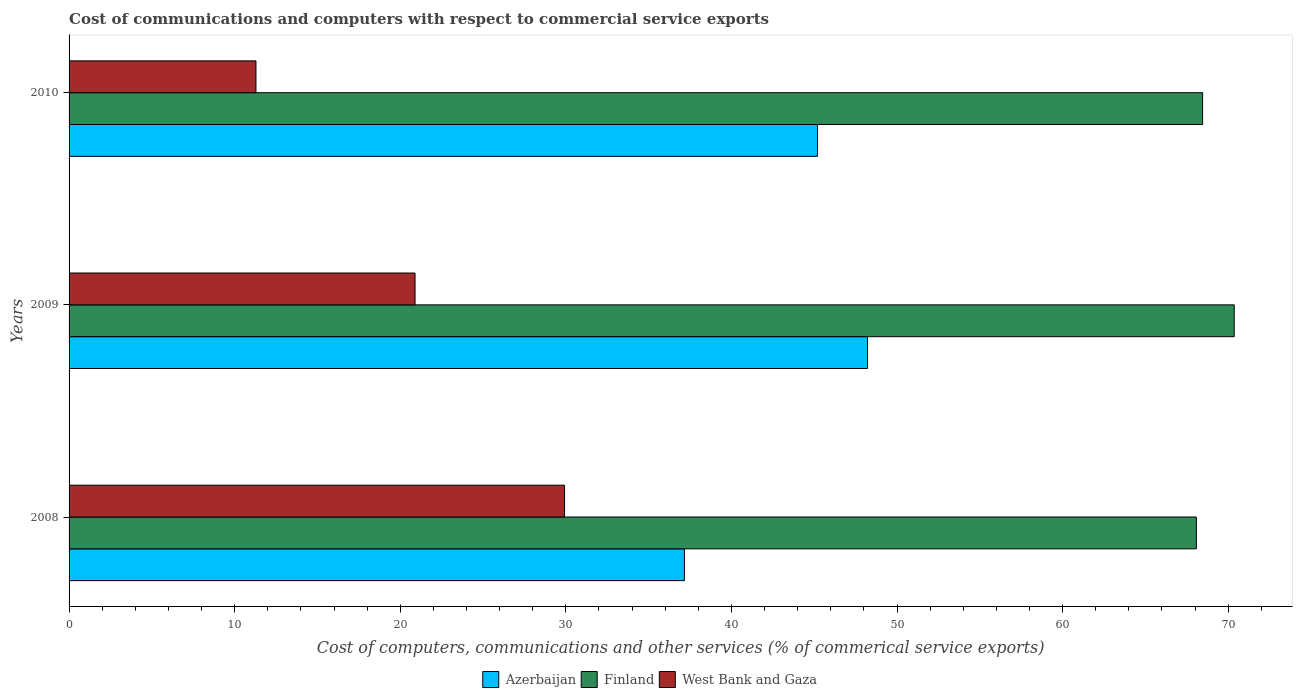How many different coloured bars are there?
Make the answer very short. 3. Are the number of bars per tick equal to the number of legend labels?
Your response must be concise. Yes. How many bars are there on the 2nd tick from the top?
Ensure brevity in your answer.  3. What is the label of the 1st group of bars from the top?
Your response must be concise. 2010. In how many cases, is the number of bars for a given year not equal to the number of legend labels?
Provide a short and direct response. 0. What is the cost of communications and computers in Finland in 2010?
Make the answer very short. 68.46. Across all years, what is the maximum cost of communications and computers in Azerbaijan?
Your answer should be very brief. 48.22. Across all years, what is the minimum cost of communications and computers in West Bank and Gaza?
Your response must be concise. 11.29. In which year was the cost of communications and computers in West Bank and Gaza maximum?
Provide a succinct answer. 2008. In which year was the cost of communications and computers in Finland minimum?
Your answer should be compact. 2008. What is the total cost of communications and computers in Azerbaijan in the graph?
Your answer should be compact. 130.58. What is the difference between the cost of communications and computers in West Bank and Gaza in 2008 and that in 2009?
Your answer should be compact. 9.03. What is the difference between the cost of communications and computers in West Bank and Gaza in 2009 and the cost of communications and computers in Finland in 2008?
Your answer should be compact. -47.19. What is the average cost of communications and computers in West Bank and Gaza per year?
Your answer should be very brief. 20.7. In the year 2008, what is the difference between the cost of communications and computers in Finland and cost of communications and computers in West Bank and Gaza?
Offer a terse response. 38.16. In how many years, is the cost of communications and computers in Azerbaijan greater than 2 %?
Provide a succinct answer. 3. What is the ratio of the cost of communications and computers in Azerbaijan in 2008 to that in 2010?
Your answer should be compact. 0.82. What is the difference between the highest and the second highest cost of communications and computers in Azerbaijan?
Offer a terse response. 3.02. What is the difference between the highest and the lowest cost of communications and computers in West Bank and Gaza?
Make the answer very short. 18.64. Is the sum of the cost of communications and computers in West Bank and Gaza in 2009 and 2010 greater than the maximum cost of communications and computers in Finland across all years?
Offer a terse response. No. What does the 1st bar from the top in 2008 represents?
Provide a short and direct response. West Bank and Gaza. What does the 3rd bar from the bottom in 2009 represents?
Provide a short and direct response. West Bank and Gaza. Is it the case that in every year, the sum of the cost of communications and computers in Finland and cost of communications and computers in West Bank and Gaza is greater than the cost of communications and computers in Azerbaijan?
Provide a succinct answer. Yes. How many bars are there?
Keep it short and to the point. 9. Are the values on the major ticks of X-axis written in scientific E-notation?
Make the answer very short. No. Does the graph contain grids?
Give a very brief answer. No. How are the legend labels stacked?
Ensure brevity in your answer.  Horizontal. What is the title of the graph?
Provide a succinct answer. Cost of communications and computers with respect to commercial service exports. What is the label or title of the X-axis?
Your answer should be very brief. Cost of computers, communications and other services (% of commerical service exports). What is the Cost of computers, communications and other services (% of commerical service exports) in Azerbaijan in 2008?
Give a very brief answer. 37.16. What is the Cost of computers, communications and other services (% of commerical service exports) in Finland in 2008?
Your answer should be compact. 68.08. What is the Cost of computers, communications and other services (% of commerical service exports) of West Bank and Gaza in 2008?
Ensure brevity in your answer.  29.92. What is the Cost of computers, communications and other services (% of commerical service exports) of Azerbaijan in 2009?
Your response must be concise. 48.22. What is the Cost of computers, communications and other services (% of commerical service exports) in Finland in 2009?
Make the answer very short. 70.37. What is the Cost of computers, communications and other services (% of commerical service exports) of West Bank and Gaza in 2009?
Give a very brief answer. 20.89. What is the Cost of computers, communications and other services (% of commerical service exports) of Azerbaijan in 2010?
Provide a short and direct response. 45.2. What is the Cost of computers, communications and other services (% of commerical service exports) of Finland in 2010?
Ensure brevity in your answer.  68.46. What is the Cost of computers, communications and other services (% of commerical service exports) in West Bank and Gaza in 2010?
Keep it short and to the point. 11.29. Across all years, what is the maximum Cost of computers, communications and other services (% of commerical service exports) in Azerbaijan?
Give a very brief answer. 48.22. Across all years, what is the maximum Cost of computers, communications and other services (% of commerical service exports) of Finland?
Keep it short and to the point. 70.37. Across all years, what is the maximum Cost of computers, communications and other services (% of commerical service exports) in West Bank and Gaza?
Your response must be concise. 29.92. Across all years, what is the minimum Cost of computers, communications and other services (% of commerical service exports) in Azerbaijan?
Provide a succinct answer. 37.16. Across all years, what is the minimum Cost of computers, communications and other services (% of commerical service exports) of Finland?
Your answer should be compact. 68.08. Across all years, what is the minimum Cost of computers, communications and other services (% of commerical service exports) of West Bank and Gaza?
Keep it short and to the point. 11.29. What is the total Cost of computers, communications and other services (% of commerical service exports) in Azerbaijan in the graph?
Ensure brevity in your answer.  130.58. What is the total Cost of computers, communications and other services (% of commerical service exports) in Finland in the graph?
Your answer should be very brief. 206.9. What is the total Cost of computers, communications and other services (% of commerical service exports) in West Bank and Gaza in the graph?
Provide a succinct answer. 62.1. What is the difference between the Cost of computers, communications and other services (% of commerical service exports) of Azerbaijan in 2008 and that in 2009?
Your answer should be very brief. -11.06. What is the difference between the Cost of computers, communications and other services (% of commerical service exports) of Finland in 2008 and that in 2009?
Your answer should be very brief. -2.29. What is the difference between the Cost of computers, communications and other services (% of commerical service exports) in West Bank and Gaza in 2008 and that in 2009?
Give a very brief answer. 9.03. What is the difference between the Cost of computers, communications and other services (% of commerical service exports) of Azerbaijan in 2008 and that in 2010?
Ensure brevity in your answer.  -8.04. What is the difference between the Cost of computers, communications and other services (% of commerical service exports) in Finland in 2008 and that in 2010?
Provide a succinct answer. -0.38. What is the difference between the Cost of computers, communications and other services (% of commerical service exports) in West Bank and Gaza in 2008 and that in 2010?
Keep it short and to the point. 18.64. What is the difference between the Cost of computers, communications and other services (% of commerical service exports) of Azerbaijan in 2009 and that in 2010?
Offer a very short reply. 3.02. What is the difference between the Cost of computers, communications and other services (% of commerical service exports) of Finland in 2009 and that in 2010?
Your answer should be compact. 1.91. What is the difference between the Cost of computers, communications and other services (% of commerical service exports) of West Bank and Gaza in 2009 and that in 2010?
Make the answer very short. 9.61. What is the difference between the Cost of computers, communications and other services (% of commerical service exports) of Azerbaijan in 2008 and the Cost of computers, communications and other services (% of commerical service exports) of Finland in 2009?
Give a very brief answer. -33.21. What is the difference between the Cost of computers, communications and other services (% of commerical service exports) in Azerbaijan in 2008 and the Cost of computers, communications and other services (% of commerical service exports) in West Bank and Gaza in 2009?
Provide a short and direct response. 16.27. What is the difference between the Cost of computers, communications and other services (% of commerical service exports) of Finland in 2008 and the Cost of computers, communications and other services (% of commerical service exports) of West Bank and Gaza in 2009?
Provide a succinct answer. 47.19. What is the difference between the Cost of computers, communications and other services (% of commerical service exports) of Azerbaijan in 2008 and the Cost of computers, communications and other services (% of commerical service exports) of Finland in 2010?
Your response must be concise. -31.3. What is the difference between the Cost of computers, communications and other services (% of commerical service exports) in Azerbaijan in 2008 and the Cost of computers, communications and other services (% of commerical service exports) in West Bank and Gaza in 2010?
Keep it short and to the point. 25.87. What is the difference between the Cost of computers, communications and other services (% of commerical service exports) in Finland in 2008 and the Cost of computers, communications and other services (% of commerical service exports) in West Bank and Gaza in 2010?
Ensure brevity in your answer.  56.8. What is the difference between the Cost of computers, communications and other services (% of commerical service exports) in Azerbaijan in 2009 and the Cost of computers, communications and other services (% of commerical service exports) in Finland in 2010?
Your answer should be very brief. -20.24. What is the difference between the Cost of computers, communications and other services (% of commerical service exports) of Azerbaijan in 2009 and the Cost of computers, communications and other services (% of commerical service exports) of West Bank and Gaza in 2010?
Your answer should be compact. 36.93. What is the difference between the Cost of computers, communications and other services (% of commerical service exports) in Finland in 2009 and the Cost of computers, communications and other services (% of commerical service exports) in West Bank and Gaza in 2010?
Offer a terse response. 59.08. What is the average Cost of computers, communications and other services (% of commerical service exports) of Azerbaijan per year?
Offer a terse response. 43.53. What is the average Cost of computers, communications and other services (% of commerical service exports) in Finland per year?
Make the answer very short. 68.97. What is the average Cost of computers, communications and other services (% of commerical service exports) of West Bank and Gaza per year?
Make the answer very short. 20.7. In the year 2008, what is the difference between the Cost of computers, communications and other services (% of commerical service exports) of Azerbaijan and Cost of computers, communications and other services (% of commerical service exports) of Finland?
Ensure brevity in your answer.  -30.92. In the year 2008, what is the difference between the Cost of computers, communications and other services (% of commerical service exports) in Azerbaijan and Cost of computers, communications and other services (% of commerical service exports) in West Bank and Gaza?
Give a very brief answer. 7.24. In the year 2008, what is the difference between the Cost of computers, communications and other services (% of commerical service exports) in Finland and Cost of computers, communications and other services (% of commerical service exports) in West Bank and Gaza?
Give a very brief answer. 38.16. In the year 2009, what is the difference between the Cost of computers, communications and other services (% of commerical service exports) of Azerbaijan and Cost of computers, communications and other services (% of commerical service exports) of Finland?
Your response must be concise. -22.15. In the year 2009, what is the difference between the Cost of computers, communications and other services (% of commerical service exports) in Azerbaijan and Cost of computers, communications and other services (% of commerical service exports) in West Bank and Gaza?
Offer a terse response. 27.32. In the year 2009, what is the difference between the Cost of computers, communications and other services (% of commerical service exports) of Finland and Cost of computers, communications and other services (% of commerical service exports) of West Bank and Gaza?
Provide a short and direct response. 49.47. In the year 2010, what is the difference between the Cost of computers, communications and other services (% of commerical service exports) of Azerbaijan and Cost of computers, communications and other services (% of commerical service exports) of Finland?
Your answer should be very brief. -23.26. In the year 2010, what is the difference between the Cost of computers, communications and other services (% of commerical service exports) in Azerbaijan and Cost of computers, communications and other services (% of commerical service exports) in West Bank and Gaza?
Offer a terse response. 33.91. In the year 2010, what is the difference between the Cost of computers, communications and other services (% of commerical service exports) in Finland and Cost of computers, communications and other services (% of commerical service exports) in West Bank and Gaza?
Keep it short and to the point. 57.17. What is the ratio of the Cost of computers, communications and other services (% of commerical service exports) of Azerbaijan in 2008 to that in 2009?
Provide a short and direct response. 0.77. What is the ratio of the Cost of computers, communications and other services (% of commerical service exports) of Finland in 2008 to that in 2009?
Your response must be concise. 0.97. What is the ratio of the Cost of computers, communications and other services (% of commerical service exports) in West Bank and Gaza in 2008 to that in 2009?
Your answer should be very brief. 1.43. What is the ratio of the Cost of computers, communications and other services (% of commerical service exports) of Azerbaijan in 2008 to that in 2010?
Keep it short and to the point. 0.82. What is the ratio of the Cost of computers, communications and other services (% of commerical service exports) in Finland in 2008 to that in 2010?
Give a very brief answer. 0.99. What is the ratio of the Cost of computers, communications and other services (% of commerical service exports) of West Bank and Gaza in 2008 to that in 2010?
Ensure brevity in your answer.  2.65. What is the ratio of the Cost of computers, communications and other services (% of commerical service exports) of Azerbaijan in 2009 to that in 2010?
Make the answer very short. 1.07. What is the ratio of the Cost of computers, communications and other services (% of commerical service exports) in Finland in 2009 to that in 2010?
Make the answer very short. 1.03. What is the ratio of the Cost of computers, communications and other services (% of commerical service exports) in West Bank and Gaza in 2009 to that in 2010?
Offer a very short reply. 1.85. What is the difference between the highest and the second highest Cost of computers, communications and other services (% of commerical service exports) in Azerbaijan?
Provide a short and direct response. 3.02. What is the difference between the highest and the second highest Cost of computers, communications and other services (% of commerical service exports) in Finland?
Give a very brief answer. 1.91. What is the difference between the highest and the second highest Cost of computers, communications and other services (% of commerical service exports) of West Bank and Gaza?
Give a very brief answer. 9.03. What is the difference between the highest and the lowest Cost of computers, communications and other services (% of commerical service exports) of Azerbaijan?
Offer a terse response. 11.06. What is the difference between the highest and the lowest Cost of computers, communications and other services (% of commerical service exports) in Finland?
Give a very brief answer. 2.29. What is the difference between the highest and the lowest Cost of computers, communications and other services (% of commerical service exports) of West Bank and Gaza?
Your answer should be very brief. 18.64. 